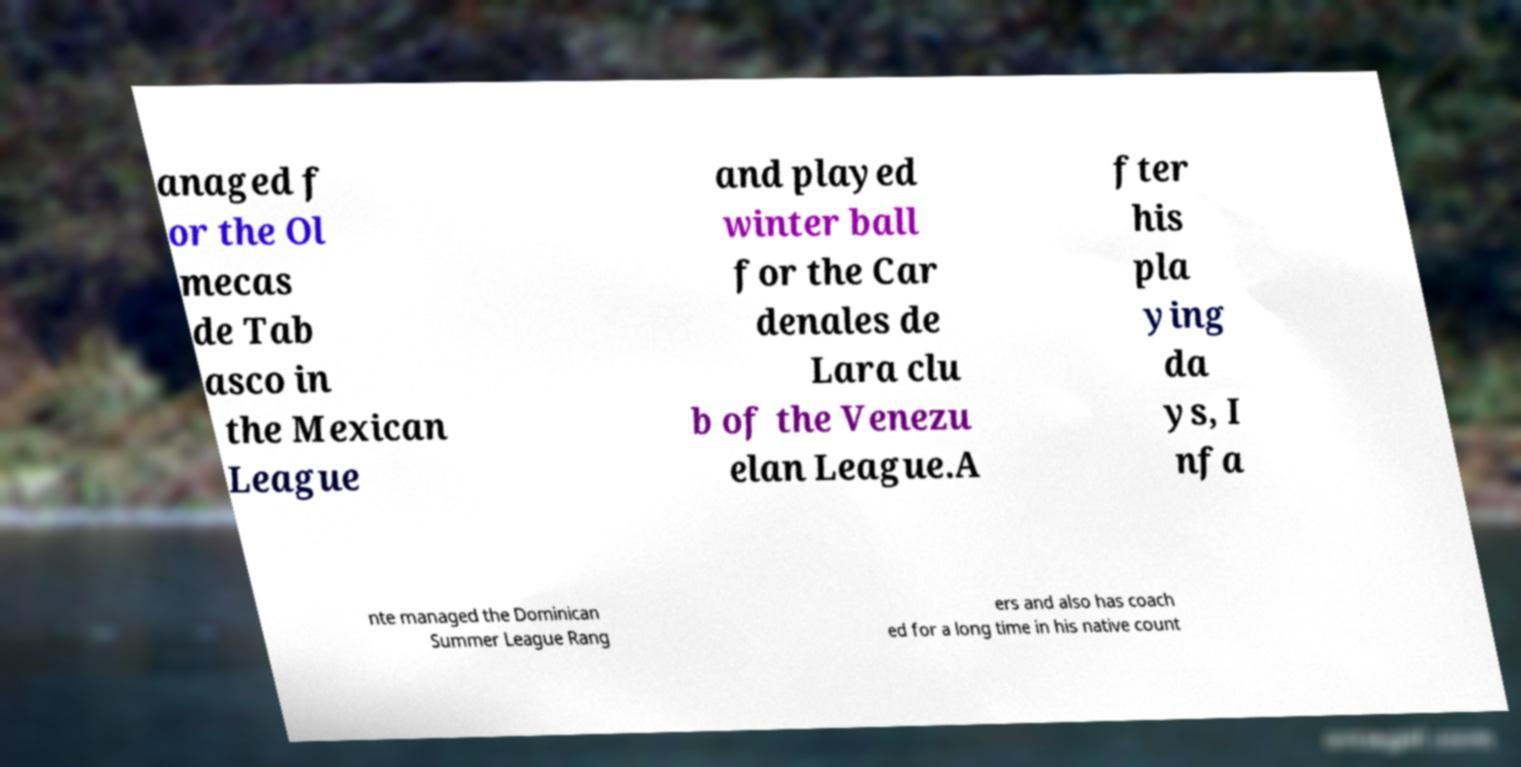Can you read and provide the text displayed in the image?This photo seems to have some interesting text. Can you extract and type it out for me? anaged f or the Ol mecas de Tab asco in the Mexican League and played winter ball for the Car denales de Lara clu b of the Venezu elan League.A fter his pla ying da ys, I nfa nte managed the Dominican Summer League Rang ers and also has coach ed for a long time in his native count 